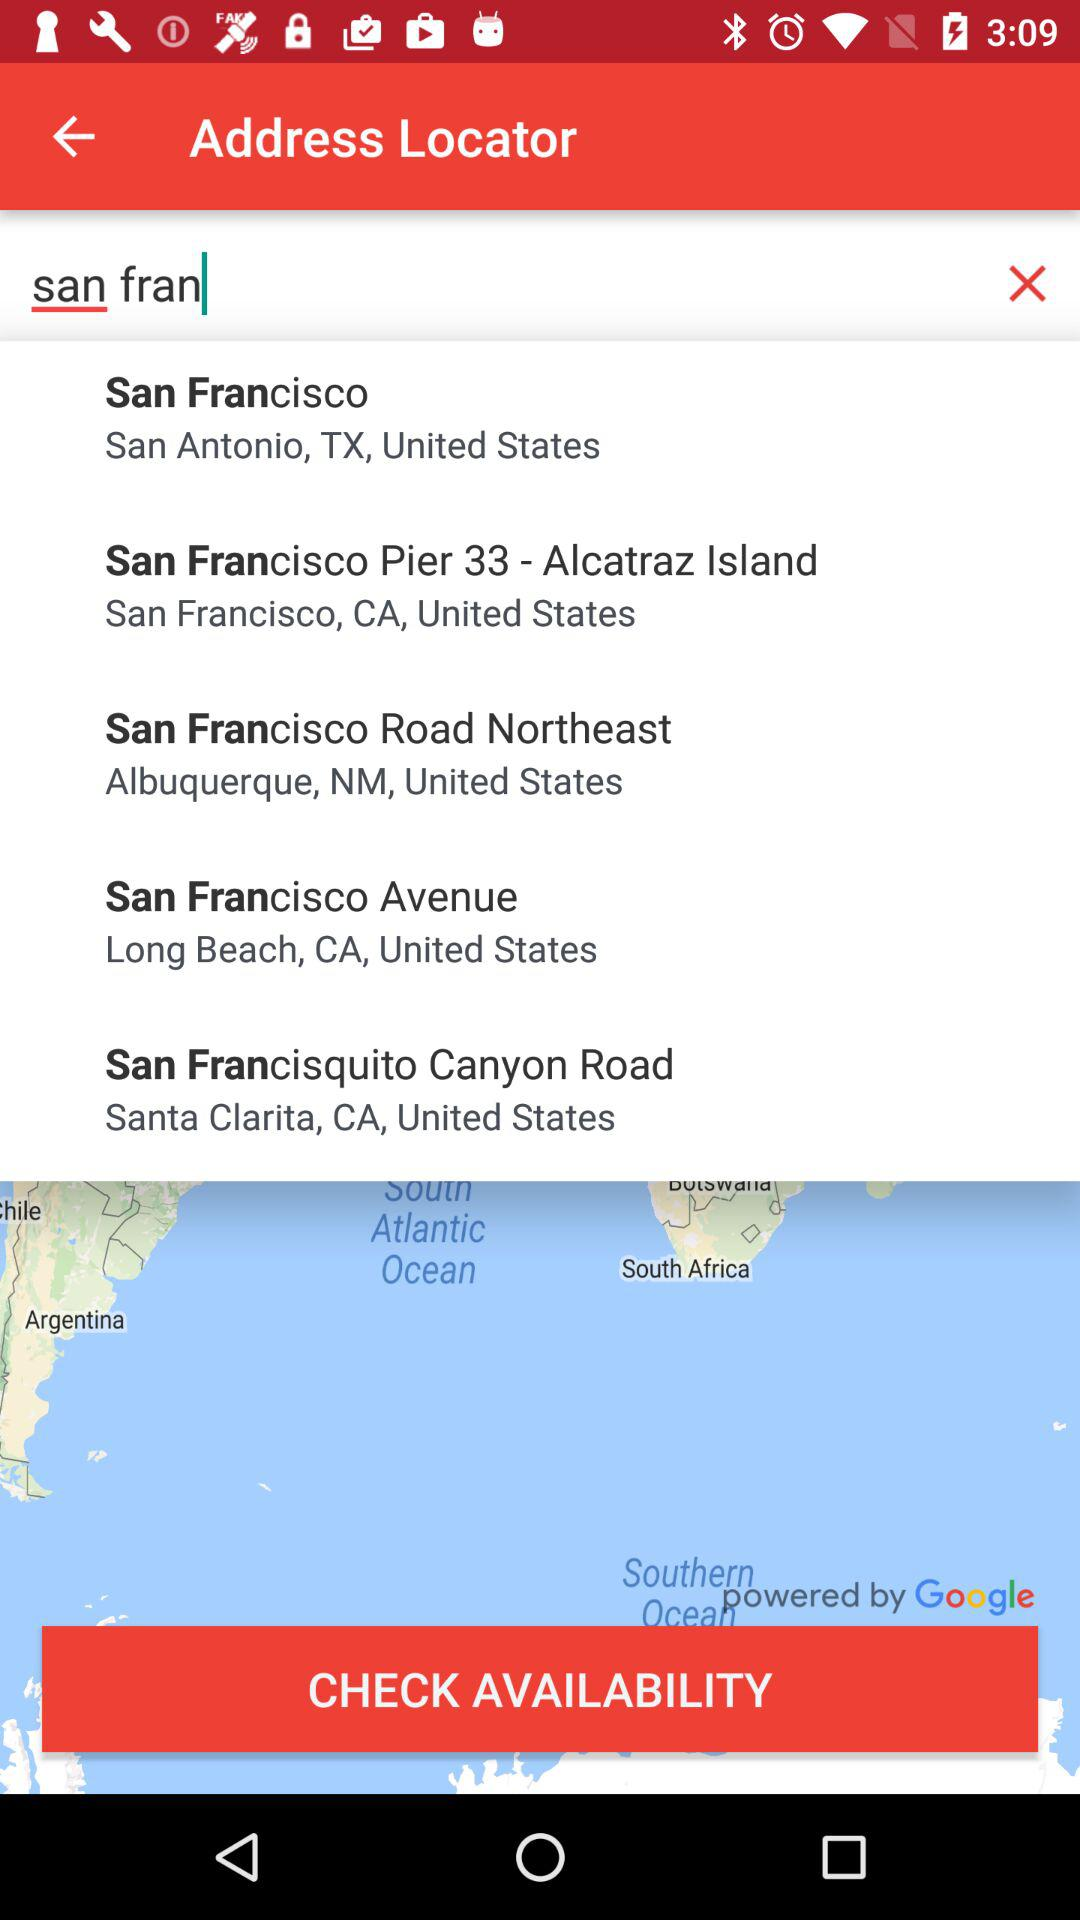How many results are there for the search "san fran"?
Answer the question using a single word or phrase. 5 